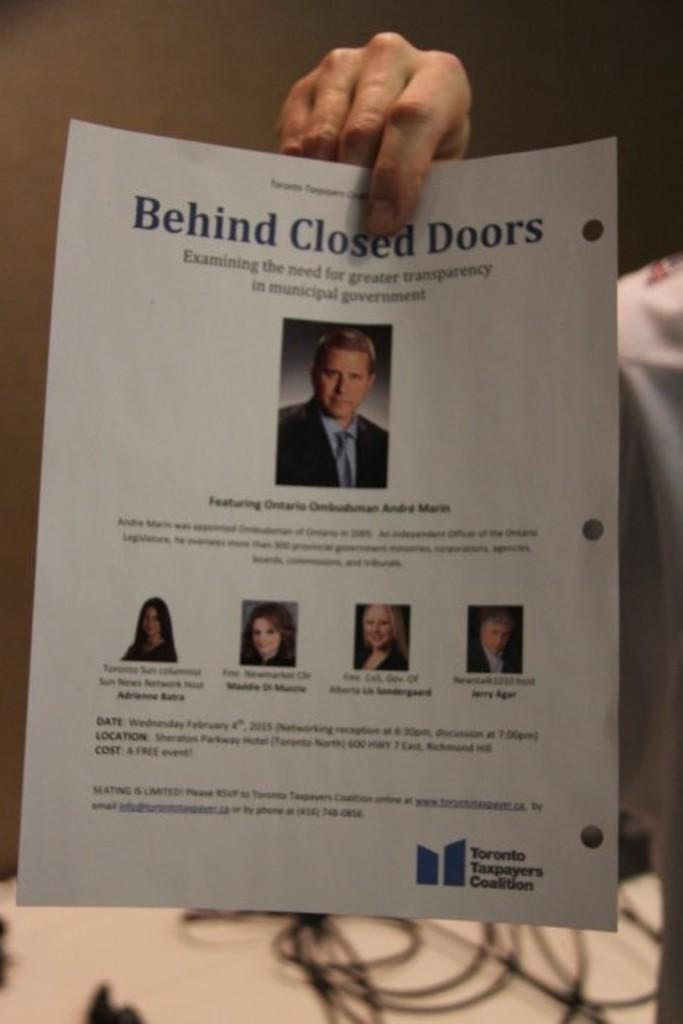What type of images are present on paper in the image? There are photographs of humans on paper in the image. What else can be seen in the image besides the photographs? There is text in the image, as well as a human hand at the top and cables at the bottom. What type of crayon is being used to draw on the oven in the image? There is no crayon or oven present in the image. What material is the brass sculpture made of in the image? There is no brass sculpture present in the image. 